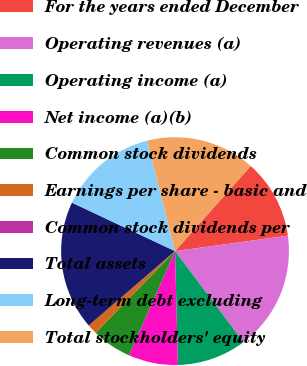Convert chart. <chart><loc_0><loc_0><loc_500><loc_500><pie_chart><fcel>For the years ended December<fcel>Operating revenues (a)<fcel>Operating income (a)<fcel>Net income (a)(b)<fcel>Common stock dividends<fcel>Earnings per share - basic and<fcel>Common stock dividends per<fcel>Total assets<fcel>Long-term debt excluding<fcel>Total stockholders' equity<nl><fcel>11.27%<fcel>16.9%<fcel>9.86%<fcel>7.04%<fcel>5.63%<fcel>1.41%<fcel>0.0%<fcel>18.31%<fcel>14.08%<fcel>15.49%<nl></chart> 